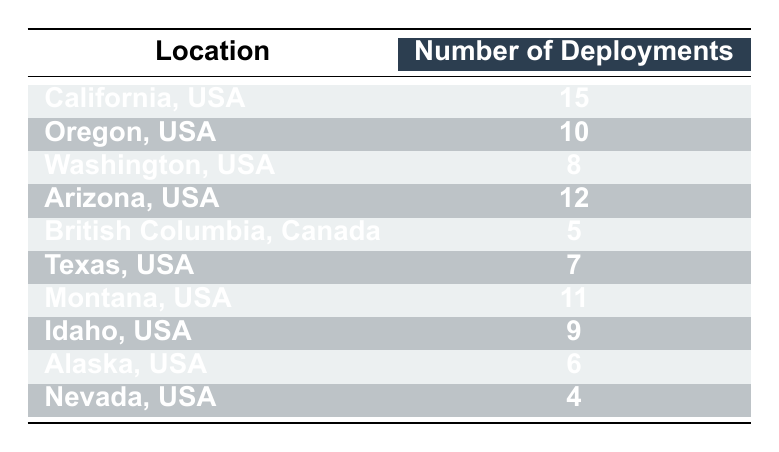What location had the highest number of smokejumper deployments? By examining the first column of the table, we see California, USA has the highest figure listed in the second column, with a total of 15 deployments.
Answer: California, USA How many smokejumper deployments were there in Oregon, USA? The table displays the number of deployments for each location, and for Oregon, USA, the value is directly seen in its respective row: 10.
Answer: 10 Which location had fewer than 8 smokejumper deployments? By looking through the table, we identify that Nevada, USA, and British Columbia, Canada, had deployments of 4 and 5 respectively, both of which are less than 8, thus confirming these two locations.
Answer: Nevada, USA; British Columbia, Canada What is the total number of smokejumper deployments across all listed locations? To find the total, we sum the deployments: 15 (California) + 10 (Oregon) + 8 (Washington) + 12 (Arizona) + 5 (British Columbia) + 7 (Texas) + 11 (Montana) + 9 (Idaho) + 6 (Alaska) + 4 (Nevada) = 87. Thus, the total number is 87 deployments.
Answer: 87 Is it true that Texas had more smokejumper deployments than Washington? Texas shows 7 deployments while Washington shows 8. Since 7 is less than 8, the assertion is false.
Answer: No What is the average number of smokejumper deployments across all the locations in the table? First, we calculated the total deployments, which is 87, and there are 10 locations. Therefore, to find the average, we divide 87 by 10, resulting in 8.7.
Answer: 8.7 Which location had the second highest number of deployments? After determining the highest deployment is 15 (California), we look for the next highest in the table. Arizona with 12 deployments is next in line, thus it is the second highest.
Answer: Arizona, USA What is the difference in the number of deployments between California and Alaska? The deployments for California are 15 while Alaska's are 6. We subtract the two figures: 15 - 6 = 9, indicating a difference of 9 deployments.
Answer: 9 